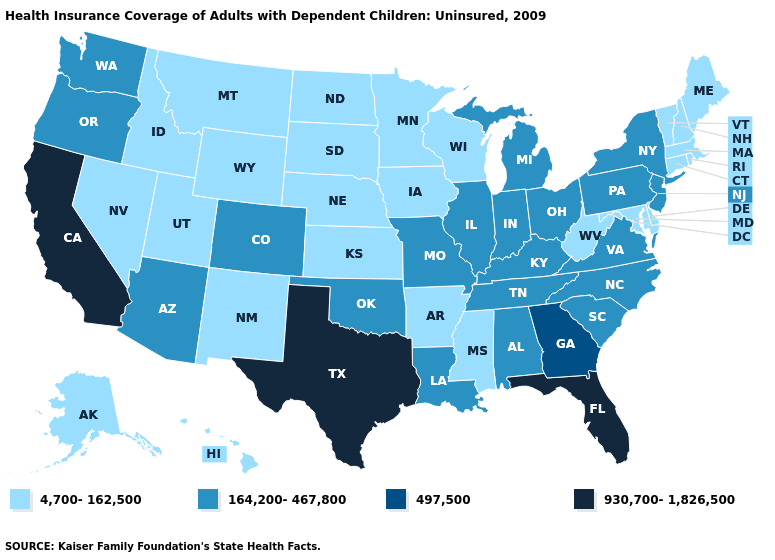Name the states that have a value in the range 497,500?
Answer briefly. Georgia. What is the lowest value in the West?
Write a very short answer. 4,700-162,500. What is the lowest value in the USA?
Give a very brief answer. 4,700-162,500. Name the states that have a value in the range 497,500?
Give a very brief answer. Georgia. Which states have the lowest value in the USA?
Be succinct. Alaska, Arkansas, Connecticut, Delaware, Hawaii, Idaho, Iowa, Kansas, Maine, Maryland, Massachusetts, Minnesota, Mississippi, Montana, Nebraska, Nevada, New Hampshire, New Mexico, North Dakota, Rhode Island, South Dakota, Utah, Vermont, West Virginia, Wisconsin, Wyoming. Does New York have a higher value than Alabama?
Concise answer only. No. Among the states that border Pennsylvania , which have the highest value?
Give a very brief answer. New Jersey, New York, Ohio. Name the states that have a value in the range 930,700-1,826,500?
Give a very brief answer. California, Florida, Texas. Does Ohio have the same value as Missouri?
Give a very brief answer. Yes. Which states have the highest value in the USA?
Be succinct. California, Florida, Texas. Name the states that have a value in the range 930,700-1,826,500?
Answer briefly. California, Florida, Texas. Does New York have a lower value than Hawaii?
Write a very short answer. No. Name the states that have a value in the range 930,700-1,826,500?
Keep it brief. California, Florida, Texas. What is the value of Arkansas?
Give a very brief answer. 4,700-162,500. Which states hav the highest value in the MidWest?
Answer briefly. Illinois, Indiana, Michigan, Missouri, Ohio. 